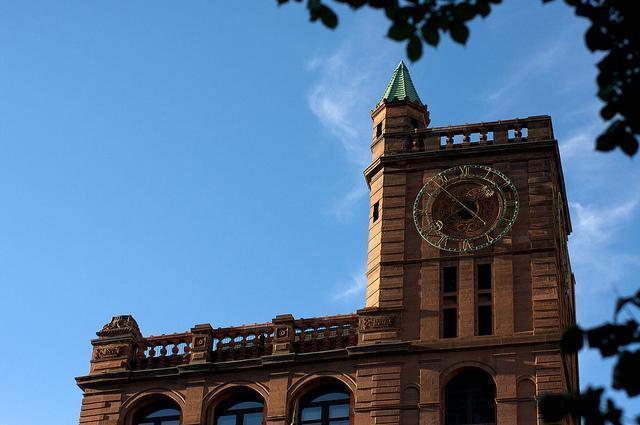How many clocks are visible?
Give a very brief answer. 1. How many cars are in the left lane?
Give a very brief answer. 0. 